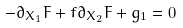<formula> <loc_0><loc_0><loc_500><loc_500>- \partial _ { X _ { 1 } } F + f \partial _ { X _ { 2 } } F + g _ { 1 } = 0</formula> 